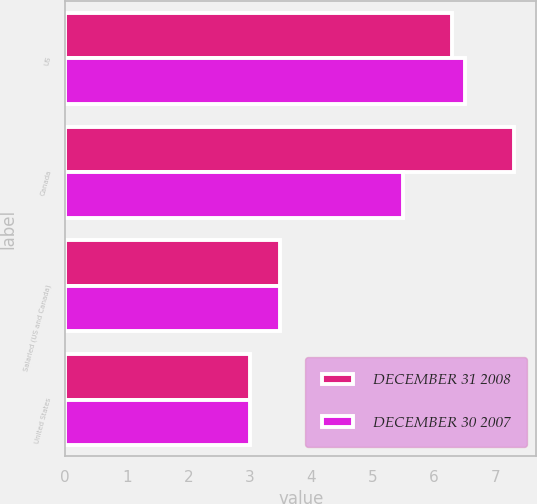<chart> <loc_0><loc_0><loc_500><loc_500><stacked_bar_chart><ecel><fcel>US<fcel>Canada<fcel>Salaried (US and Canada)<fcel>United States<nl><fcel>DECEMBER 31 2008<fcel>6.3<fcel>7.3<fcel>3.5<fcel>3<nl><fcel>DECEMBER 30 2007<fcel>6.5<fcel>5.5<fcel>3.5<fcel>3<nl></chart> 